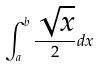<formula> <loc_0><loc_0><loc_500><loc_500>\int _ { a } ^ { b } \frac { \sqrt { x } } 2 d x</formula> 